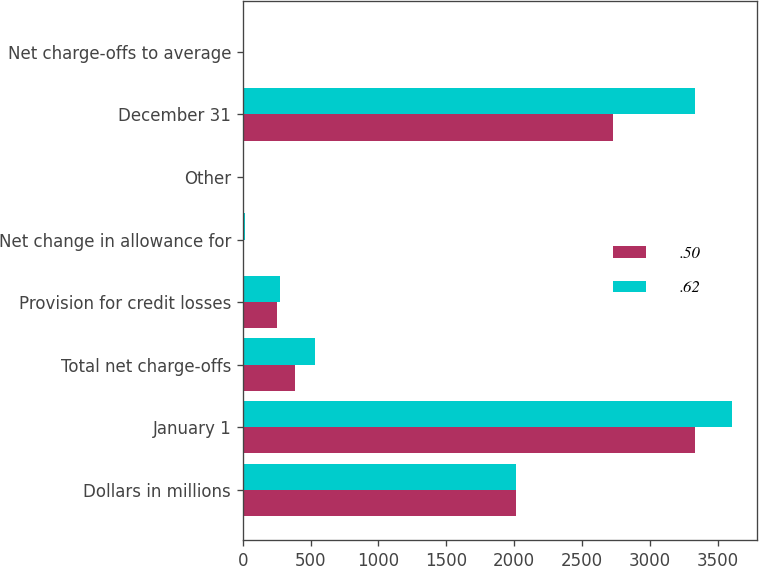Convert chart to OTSL. <chart><loc_0><loc_0><loc_500><loc_500><stacked_bar_chart><ecel><fcel>Dollars in millions<fcel>January 1<fcel>Total net charge-offs<fcel>Provision for credit losses<fcel>Net change in allowance for<fcel>Other<fcel>December 31<fcel>Net charge-offs to average<nl><fcel>0.5<fcel>2015<fcel>3331<fcel>386<fcel>255<fcel>2<fcel>3<fcel>2727<fcel>0.19<nl><fcel>0.62<fcel>2014<fcel>3609<fcel>531<fcel>273<fcel>17<fcel>3<fcel>3331<fcel>0.27<nl></chart> 